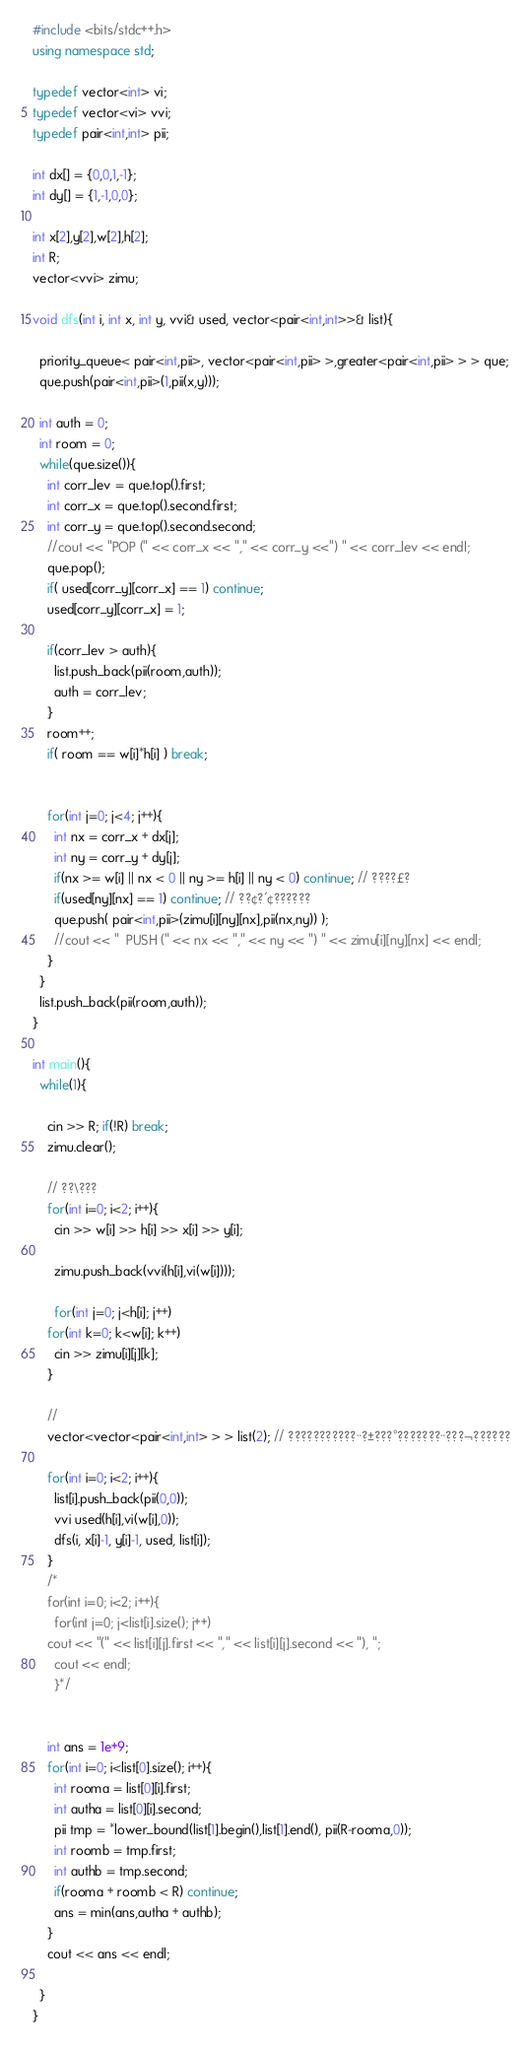Convert code to text. <code><loc_0><loc_0><loc_500><loc_500><_C++_>#include <bits/stdc++.h>
using namespace std;

typedef vector<int> vi;
typedef vector<vi> vvi;
typedef pair<int,int> pii;

int dx[] = {0,0,1,-1};
int dy[] = {1,-1,0,0};

int x[2],y[2],w[2],h[2];
int R;
vector<vvi> zimu;

void dfs(int i, int x, int y, vvi& used, vector<pair<int,int>>& list){

  priority_queue< pair<int,pii>, vector<pair<int,pii> >,greater<pair<int,pii> > > que;
  que.push(pair<int,pii>(1,pii(x,y)));

  int auth = 0;
  int room = 0;
  while(que.size()){
    int corr_lev = que.top().first;
    int corr_x = que.top().second.first;
    int corr_y = que.top().second.second;
    //cout << "POP (" << corr_x << "," << corr_y <<") " << corr_lev << endl; 
    que.pop();
    if( used[corr_y][corr_x] == 1) continue;
    used[corr_y][corr_x] = 1;
    
    if(corr_lev > auth){
      list.push_back(pii(room,auth));
      auth = corr_lev;
    }
    room++;
    if( room == w[i]*h[i] ) break;


    for(int j=0; j<4; j++){
      int nx = corr_x + dx[j];
      int ny = corr_y + dy[j];
      if(nx >= w[i] || nx < 0 || ny >= h[i] || ny < 0) continue; // ????£?
      if(used[ny][nx] == 1) continue; // ??¢?´¢??????
      que.push( pair<int,pii>(zimu[i][ny][nx],pii(nx,ny)) );
      //cout << "  PUSH (" << nx << "," << ny << ") " << zimu[i][ny][nx] << endl; 
    }
  }
  list.push_back(pii(room,auth));
}

int main(){
  while(1){
  
    cin >> R; if(!R) break;
    zimu.clear();
    
    // ??\???
    for(int i=0; i<2; i++){
      cin >> w[i] >> h[i] >> x[i] >> y[i];
  
      zimu.push_back(vvi(h[i],vi(w[i])));

      for(int j=0; j<h[i]; j++)
	for(int k=0; k<w[i]; k++)
	  cin >> zimu[i][j][k];
    }

    // 
    vector<vector<pair<int,int> > > list(2); // ???????????¨?±???°???????¨???¬??????
    
    for(int i=0; i<2; i++){
      list[i].push_back(pii(0,0));
      vvi used(h[i],vi(w[i],0));
      dfs(i, x[i]-1, y[i]-1, used, list[i]);
    }
    /*
    for(int i=0; i<2; i++){
      for(int j=0; j<list[i].size(); j++)
	cout << "(" << list[i][j].first << "," << list[i][j].second << "), ";
      cout << endl;
      }*/
    

    int ans = 1e+9;
    for(int i=0; i<list[0].size(); i++){
      int rooma = list[0][i].first;
      int autha = list[0][i].second;
      pii tmp = *lower_bound(list[1].begin(),list[1].end(), pii(R-rooma,0));
      int roomb = tmp.first;
      int authb = tmp.second;
      if(rooma + roomb < R) continue;
      ans = min(ans,autha + authb);
    }
    cout << ans << endl;

  }
}</code> 